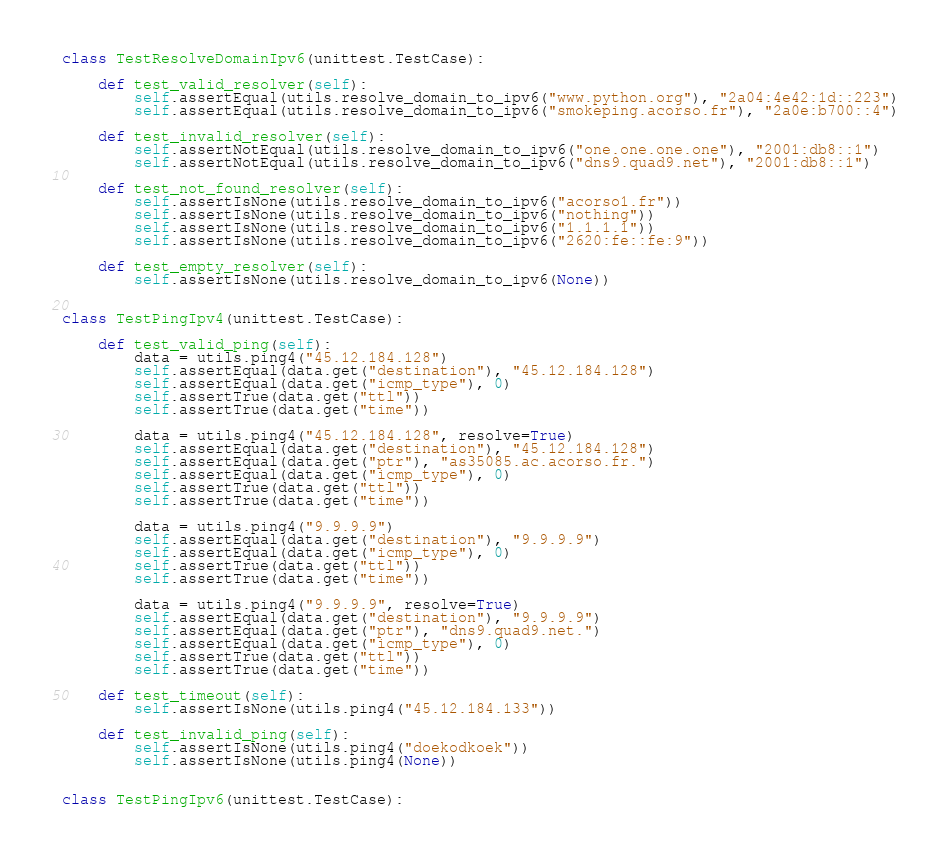Convert code to text. <code><loc_0><loc_0><loc_500><loc_500><_Python_>

class TestResolveDomainIpv6(unittest.TestCase):

    def test_valid_resolver(self):
        self.assertEqual(utils.resolve_domain_to_ipv6("www.python.org"), "2a04:4e42:1d::223")
        self.assertEqual(utils.resolve_domain_to_ipv6("smokeping.acorso.fr"), "2a0e:b700::4")

    def test_invalid_resolver(self):
        self.assertNotEqual(utils.resolve_domain_to_ipv6("one.one.one.one"), "2001:db8::1")
        self.assertNotEqual(utils.resolve_domain_to_ipv6("dns9.quad9.net"), "2001:db8::1")

    def test_not_found_resolver(self):
        self.assertIsNone(utils.resolve_domain_to_ipv6("acorso1.fr"))
        self.assertIsNone(utils.resolve_domain_to_ipv6("nothing"))
        self.assertIsNone(utils.resolve_domain_to_ipv6("1.1.1.1"))
        self.assertIsNone(utils.resolve_domain_to_ipv6("2620:fe::fe:9"))

    def test_empty_resolver(self):
        self.assertIsNone(utils.resolve_domain_to_ipv6(None))


class TestPingIpv4(unittest.TestCase):

    def test_valid_ping(self):
        data = utils.ping4("45.12.184.128")
        self.assertEqual(data.get("destination"), "45.12.184.128")
        self.assertEqual(data.get("icmp_type"), 0)
        self.assertTrue(data.get("ttl"))
        self.assertTrue(data.get("time"))

        data = utils.ping4("45.12.184.128", resolve=True)
        self.assertEqual(data.get("destination"), "45.12.184.128")
        self.assertEqual(data.get("ptr"), "as35085.ac.acorso.fr.")
        self.assertEqual(data.get("icmp_type"), 0)
        self.assertTrue(data.get("ttl"))
        self.assertTrue(data.get("time"))

        data = utils.ping4("9.9.9.9")
        self.assertEqual(data.get("destination"), "9.9.9.9")
        self.assertEqual(data.get("icmp_type"), 0)
        self.assertTrue(data.get("ttl"))
        self.assertTrue(data.get("time"))

        data = utils.ping4("9.9.9.9", resolve=True)
        self.assertEqual(data.get("destination"), "9.9.9.9")
        self.assertEqual(data.get("ptr"), "dns9.quad9.net.")
        self.assertEqual(data.get("icmp_type"), 0)
        self.assertTrue(data.get("ttl"))
        self.assertTrue(data.get("time"))

    def test_timeout(self):
        self.assertIsNone(utils.ping4("45.12.184.133"))

    def test_invalid_ping(self):
        self.assertIsNone(utils.ping4("doekodkoek"))
        self.assertIsNone(utils.ping4(None))


class TestPingIpv6(unittest.TestCase):
</code> 